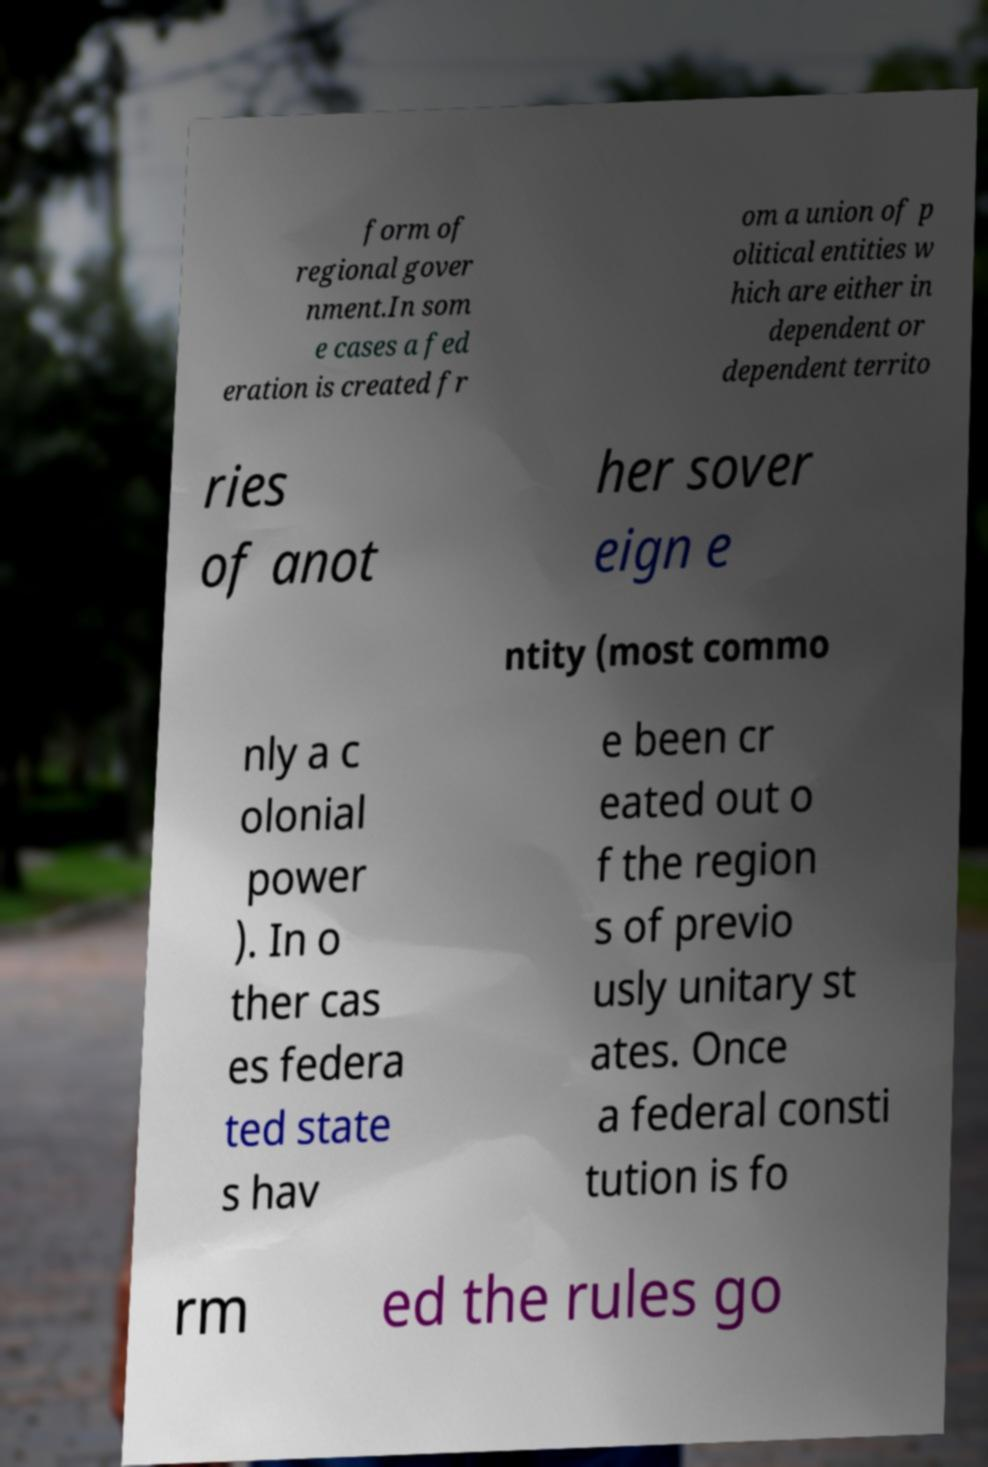I need the written content from this picture converted into text. Can you do that? form of regional gover nment.In som e cases a fed eration is created fr om a union of p olitical entities w hich are either in dependent or dependent territo ries of anot her sover eign e ntity (most commo nly a c olonial power ). In o ther cas es federa ted state s hav e been cr eated out o f the region s of previo usly unitary st ates. Once a federal consti tution is fo rm ed the rules go 